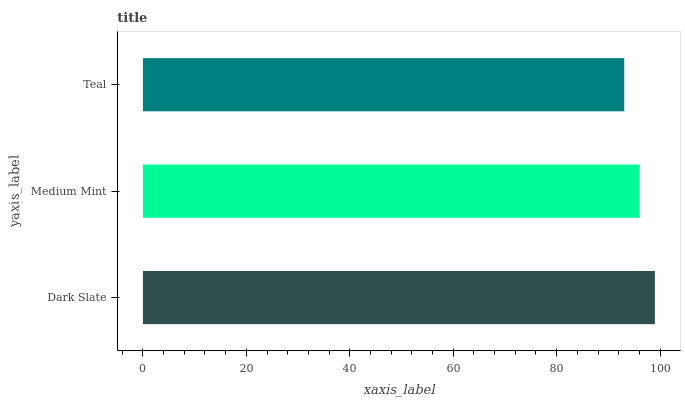Is Teal the minimum?
Answer yes or no. Yes. Is Dark Slate the maximum?
Answer yes or no. Yes. Is Medium Mint the minimum?
Answer yes or no. No. Is Medium Mint the maximum?
Answer yes or no. No. Is Dark Slate greater than Medium Mint?
Answer yes or no. Yes. Is Medium Mint less than Dark Slate?
Answer yes or no. Yes. Is Medium Mint greater than Dark Slate?
Answer yes or no. No. Is Dark Slate less than Medium Mint?
Answer yes or no. No. Is Medium Mint the high median?
Answer yes or no. Yes. Is Medium Mint the low median?
Answer yes or no. Yes. Is Teal the high median?
Answer yes or no. No. Is Dark Slate the low median?
Answer yes or no. No. 